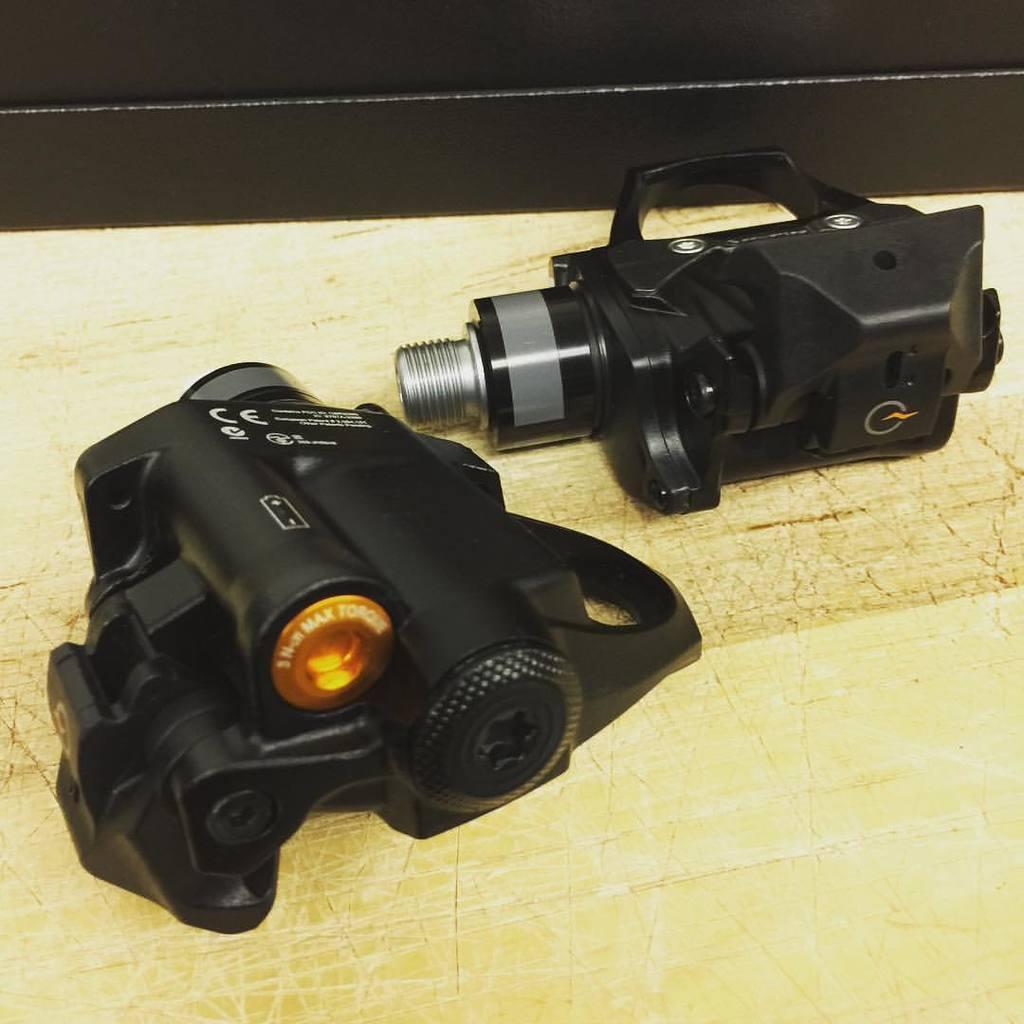Describe this image in one or two sentences. The picture consists of a camera placed on a desk. 